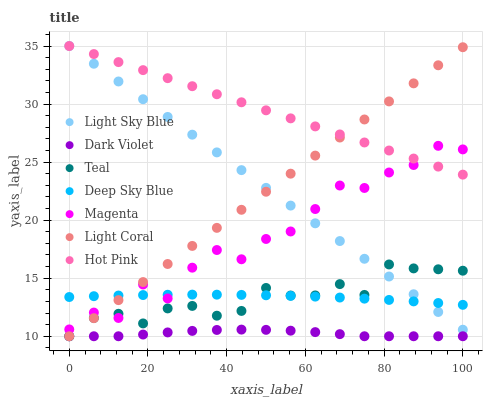Does Dark Violet have the minimum area under the curve?
Answer yes or no. Yes. Does Hot Pink have the maximum area under the curve?
Answer yes or no. Yes. Does Hot Pink have the minimum area under the curve?
Answer yes or no. No. Does Dark Violet have the maximum area under the curve?
Answer yes or no. No. Is Light Coral the smoothest?
Answer yes or no. Yes. Is Magenta the roughest?
Answer yes or no. Yes. Is Hot Pink the smoothest?
Answer yes or no. No. Is Hot Pink the roughest?
Answer yes or no. No. Does Teal have the lowest value?
Answer yes or no. Yes. Does Hot Pink have the lowest value?
Answer yes or no. No. Does Light Sky Blue have the highest value?
Answer yes or no. Yes. Does Dark Violet have the highest value?
Answer yes or no. No. Is Deep Sky Blue less than Hot Pink?
Answer yes or no. Yes. Is Deep Sky Blue greater than Dark Violet?
Answer yes or no. Yes. Does Dark Violet intersect Light Coral?
Answer yes or no. Yes. Is Dark Violet less than Light Coral?
Answer yes or no. No. Is Dark Violet greater than Light Coral?
Answer yes or no. No. Does Deep Sky Blue intersect Hot Pink?
Answer yes or no. No. 